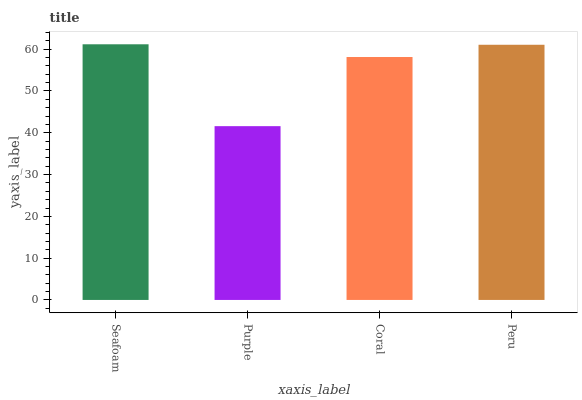Is Purple the minimum?
Answer yes or no. Yes. Is Seafoam the maximum?
Answer yes or no. Yes. Is Coral the minimum?
Answer yes or no. No. Is Coral the maximum?
Answer yes or no. No. Is Coral greater than Purple?
Answer yes or no. Yes. Is Purple less than Coral?
Answer yes or no. Yes. Is Purple greater than Coral?
Answer yes or no. No. Is Coral less than Purple?
Answer yes or no. No. Is Peru the high median?
Answer yes or no. Yes. Is Coral the low median?
Answer yes or no. Yes. Is Coral the high median?
Answer yes or no. No. Is Peru the low median?
Answer yes or no. No. 